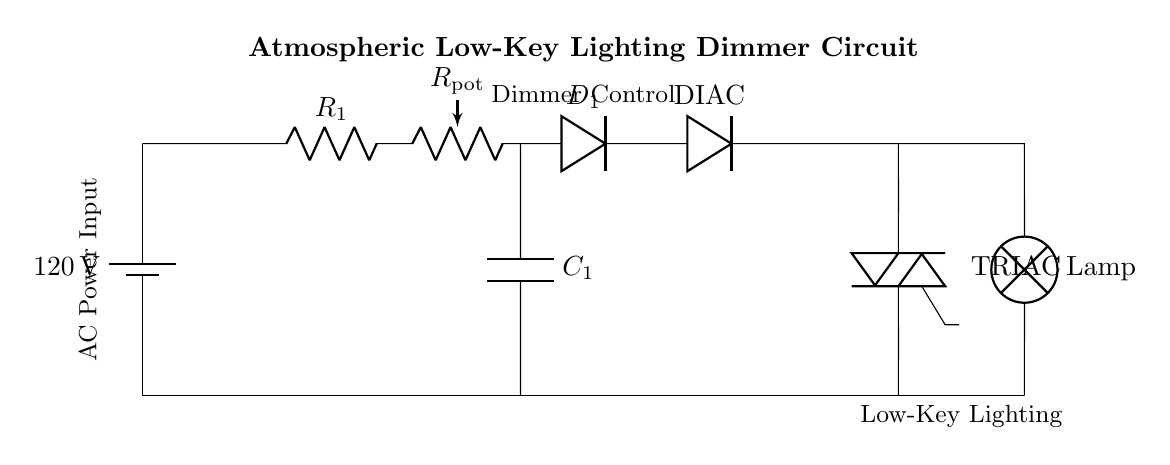What is the voltage of the power supply? The voltage of the power supply is specified as 120 volts in the diagram, noted next to the battery icon.
Answer: 120 volts What component is labeled as R1? R1 is identified in the circuit as a resistor that is connected in series with the other components, evident from the symbol and label near it.
Answer: Resistor What does the capacitor C1 do in this circuit? C1 is a capacitor connected to the potentiometer, which helps in stabilizing and smoothing the output voltage for dimming control.
Answer: Stabilizing How many resistors are present in the circuit? There is one resistor labeled as R1 and another variable resistor labeled as Rpot, which counts as two resistors in total.
Answer: Two What is the role of the TRIAC in the circuit? The TRIAC is used to control the power supplied to the lamp by allowing current to flow in both directions and is crucial in adjusting the brightness of the light.
Answer: Power control What is the significance of the DIAC in this dimmer circuit? The DIAC is a device that helps to switch the TRIAC on and off precisely, allowing for controlled firing of the TRIAC at certain voltage levels for dimming functionality.
Answer: Controlled switching How does Rpot affect the dimming process? Rpot is a potentiometer that adjusts the resistance in the circuit, allowing the user to control the voltage reaching the TRIAC and ultimately the brightness of the lamp.
Answer: Brightness control 